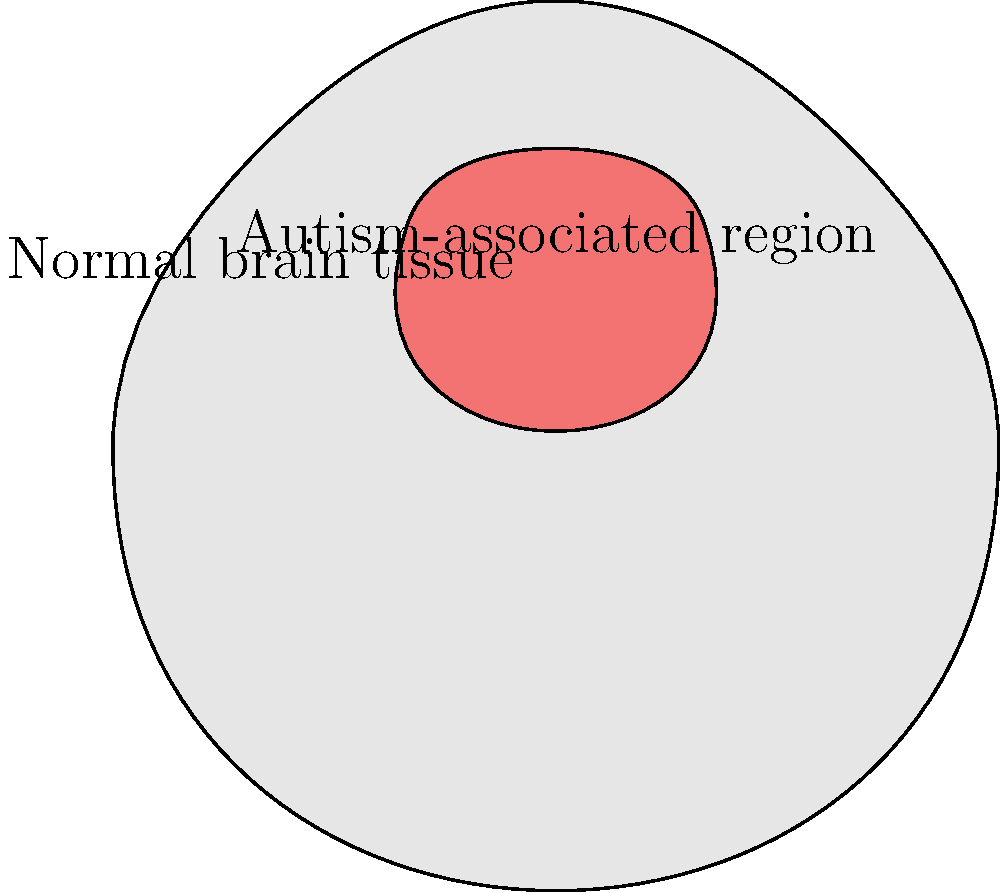In analyzing brain MRI scans for autism detection, which machine learning technique would be most appropriate for identifying structural differences in specific brain regions, as shown in the red highlighted area of the image? To answer this question, let's consider the steps involved in analyzing brain MRI scans for autism detection:

1. Data collection: Obtain MRI scans of both autistic and non-autistic individuals.

2. Preprocessing: Normalize the MRI images to ensure consistency across scans.

3. Feature extraction: Identify relevant features from the MRI scans, such as the size, shape, and density of specific brain regions (like the red highlighted area in the image).

4. Classification: Use a machine learning algorithm to classify scans as either autistic or non-autistic based on the extracted features.

5. Localization: Identify which specific brain regions (like the red area) contribute most to the classification.

Given these steps, the most appropriate machine learning technique for this task would be Convolutional Neural Networks (CNNs). CNNs are particularly well-suited for image analysis tasks because:

a) They can automatically learn relevant features from the raw image data.
b) They can capture spatial relationships in the image, which is crucial for identifying structural differences in specific brain regions.
c) They can be used for both classification (autistic vs. non-autistic) and localization (identifying which regions contribute most to the classification).
d) They have shown excellent performance in medical image analysis tasks, including brain MRI analysis.

Other techniques like Support Vector Machines (SVMs) or Random Forests could also be used, but they would require more manual feature engineering and may not capture the spatial relationships as effectively as CNNs.
Answer: Convolutional Neural Networks (CNNs) 